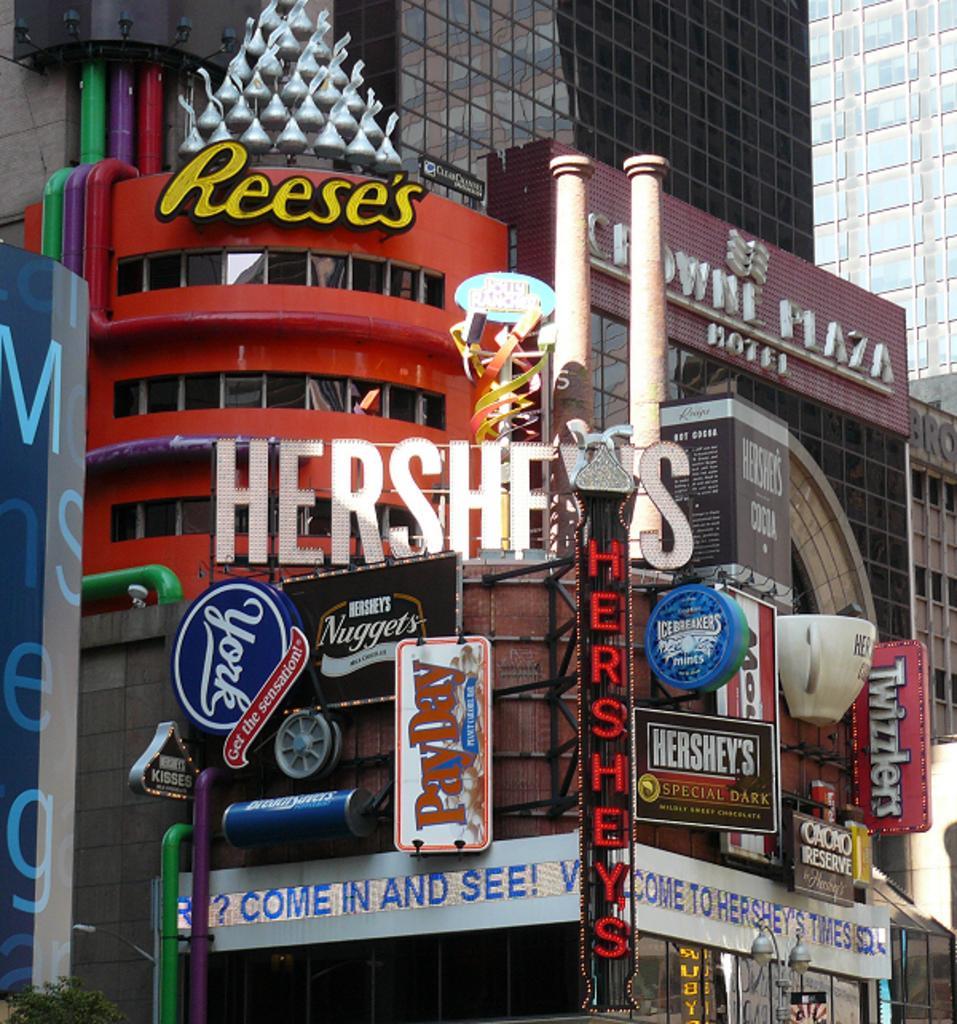Please provide a concise description of this image. In this image, I can see the buildings with the glass doors. These are the name boards, which are attached to the buildings. 